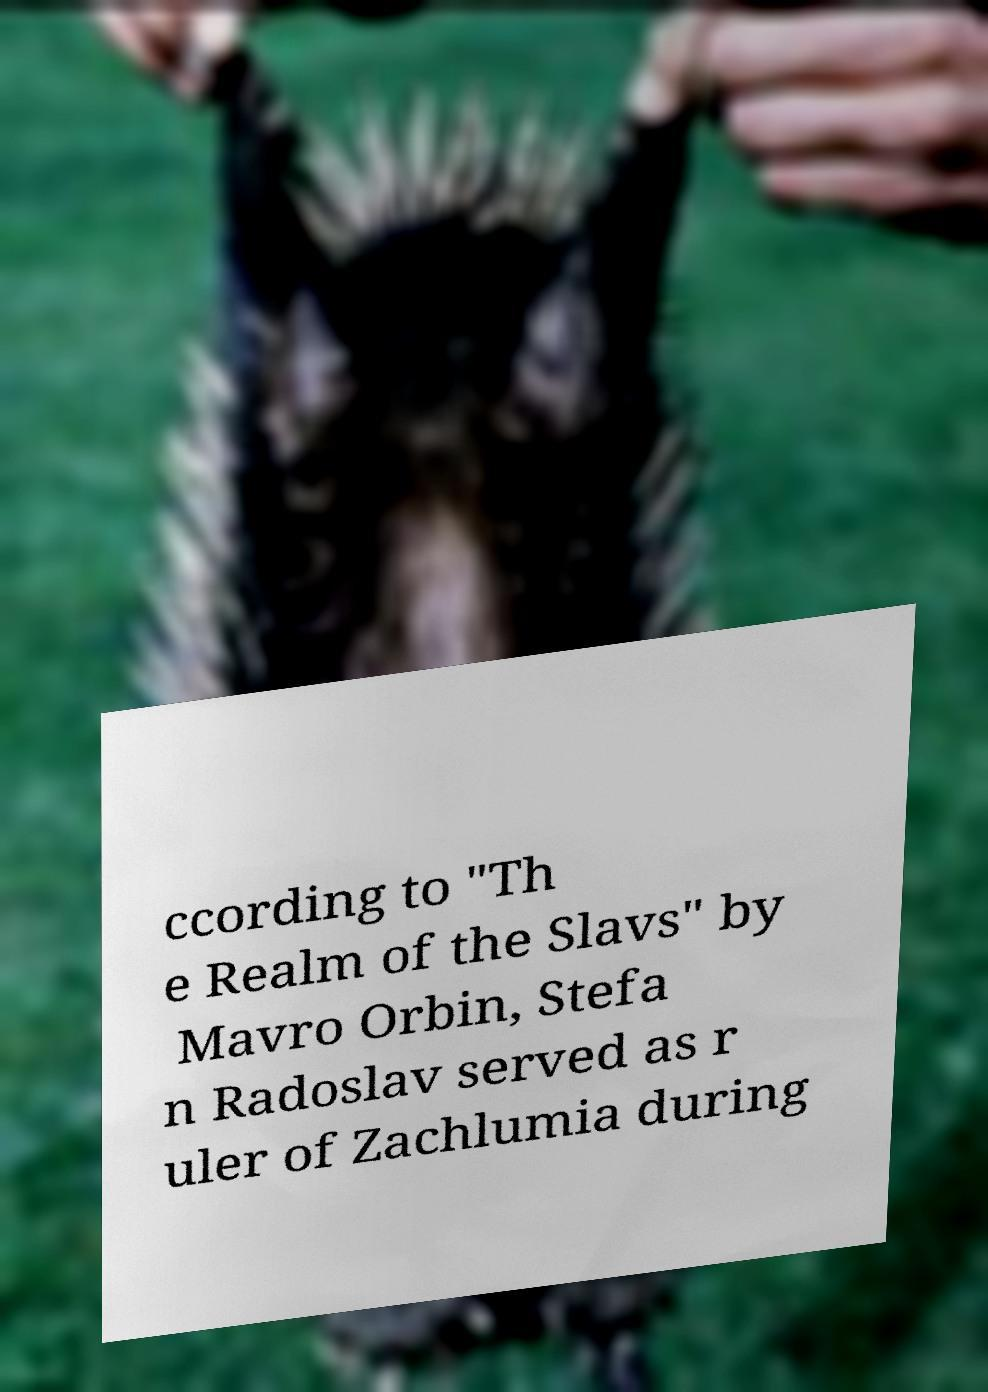Can you read and provide the text displayed in the image?This photo seems to have some interesting text. Can you extract and type it out for me? ccording to "Th e Realm of the Slavs" by Mavro Orbin, Stefa n Radoslav served as r uler of Zachlumia during 